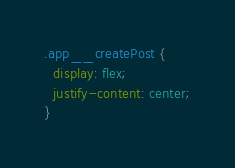Convert code to text. <code><loc_0><loc_0><loc_500><loc_500><_CSS_>
.app__createPost {
  display: flex;
  justify-content: center;
}
</code> 